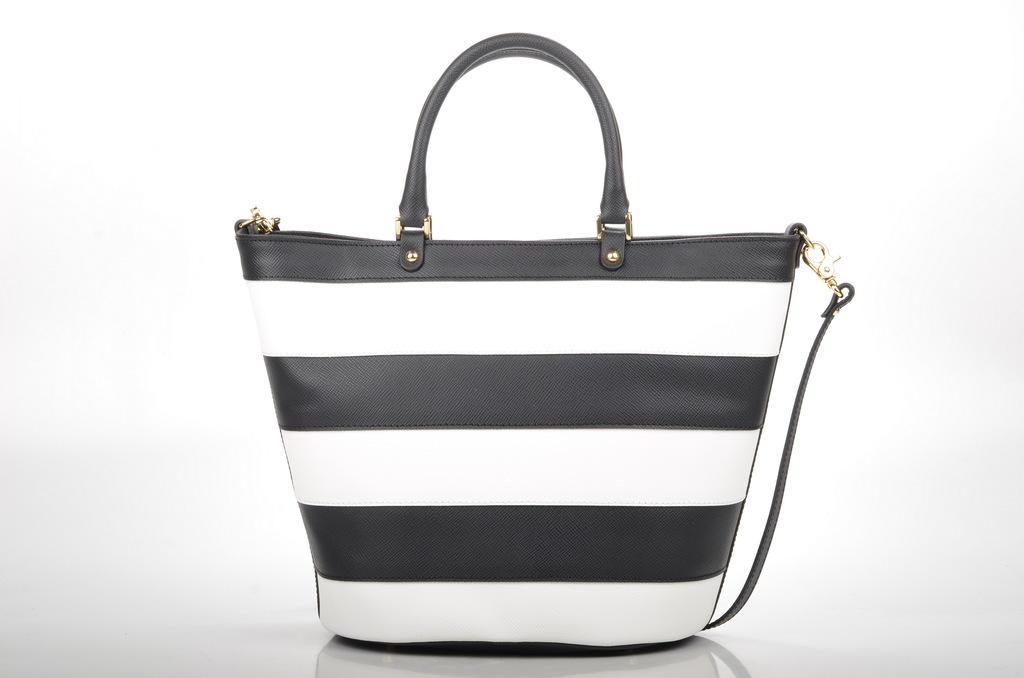Could you give a brief overview of what you see in this image? There is a black and white handbag and the background is white in color. 